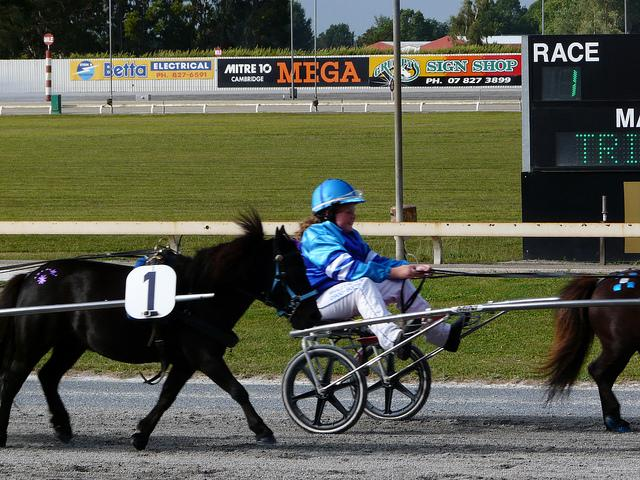What is this activity? Please explain your reasoning. race. This is a jocket behind a race horse on a track 